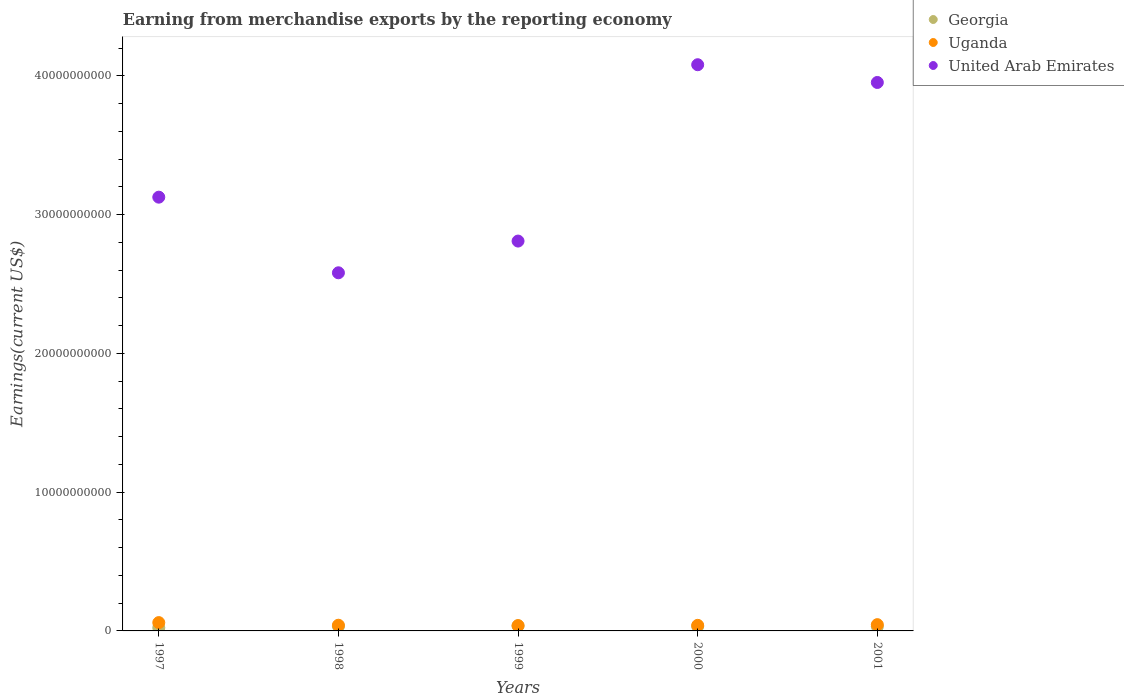What is the amount earned from merchandise exports in Georgia in 1997?
Keep it short and to the point. 2.30e+08. Across all years, what is the maximum amount earned from merchandise exports in United Arab Emirates?
Offer a terse response. 4.08e+1. Across all years, what is the minimum amount earned from merchandise exports in Uganda?
Offer a terse response. 3.85e+08. What is the total amount earned from merchandise exports in United Arab Emirates in the graph?
Offer a very short reply. 1.66e+11. What is the difference between the amount earned from merchandise exports in Uganda in 1999 and that in 2001?
Keep it short and to the point. -6.70e+07. What is the difference between the amount earned from merchandise exports in Uganda in 1997 and the amount earned from merchandise exports in Georgia in 1999?
Make the answer very short. 2.39e+08. What is the average amount earned from merchandise exports in Uganda per year?
Your answer should be compact. 4.50e+08. In the year 2001, what is the difference between the amount earned from merchandise exports in Uganda and amount earned from merchandise exports in United Arab Emirates?
Ensure brevity in your answer.  -3.91e+1. In how many years, is the amount earned from merchandise exports in Uganda greater than 20000000000 US$?
Your answer should be compact. 0. What is the ratio of the amount earned from merchandise exports in United Arab Emirates in 1998 to that in 2000?
Your answer should be compact. 0.63. Is the amount earned from merchandise exports in Uganda in 2000 less than that in 2001?
Offer a terse response. Yes. Is the difference between the amount earned from merchandise exports in Uganda in 2000 and 2001 greater than the difference between the amount earned from merchandise exports in United Arab Emirates in 2000 and 2001?
Your response must be concise. No. What is the difference between the highest and the second highest amount earned from merchandise exports in Georgia?
Your response must be concise. 3.02e+07. What is the difference between the highest and the lowest amount earned from merchandise exports in Uganda?
Keep it short and to the point. 2.15e+08. In how many years, is the amount earned from merchandise exports in Georgia greater than the average amount earned from merchandise exports in Georgia taken over all years?
Provide a short and direct response. 4. Is it the case that in every year, the sum of the amount earned from merchandise exports in United Arab Emirates and amount earned from merchandise exports in Uganda  is greater than the amount earned from merchandise exports in Georgia?
Ensure brevity in your answer.  Yes. Does the amount earned from merchandise exports in United Arab Emirates monotonically increase over the years?
Your response must be concise. No. Is the amount earned from merchandise exports in Uganda strictly less than the amount earned from merchandise exports in Georgia over the years?
Offer a very short reply. No. How many dotlines are there?
Provide a succinct answer. 3. How many legend labels are there?
Provide a short and direct response. 3. How are the legend labels stacked?
Your answer should be very brief. Vertical. What is the title of the graph?
Provide a succinct answer. Earning from merchandise exports by the reporting economy. What is the label or title of the Y-axis?
Your answer should be compact. Earnings(current US$). What is the Earnings(current US$) in Georgia in 1997?
Keep it short and to the point. 2.30e+08. What is the Earnings(current US$) of Uganda in 1997?
Your answer should be compact. 6.00e+08. What is the Earnings(current US$) in United Arab Emirates in 1997?
Provide a succinct answer. 3.13e+1. What is the Earnings(current US$) of Georgia in 1998?
Your response must be concise. 3.31e+08. What is the Earnings(current US$) in Uganda in 1998?
Provide a short and direct response. 4.11e+08. What is the Earnings(current US$) of United Arab Emirates in 1998?
Your response must be concise. 2.58e+1. What is the Earnings(current US$) in Georgia in 1999?
Ensure brevity in your answer.  3.61e+08. What is the Earnings(current US$) in Uganda in 1999?
Offer a very short reply. 3.85e+08. What is the Earnings(current US$) in United Arab Emirates in 1999?
Provide a short and direct response. 2.81e+1. What is the Earnings(current US$) in Georgia in 2000?
Your answer should be compact. 3.26e+08. What is the Earnings(current US$) in Uganda in 2000?
Offer a terse response. 4.02e+08. What is the Earnings(current US$) in United Arab Emirates in 2000?
Ensure brevity in your answer.  4.08e+1. What is the Earnings(current US$) in Georgia in 2001?
Provide a short and direct response. 3.17e+08. What is the Earnings(current US$) of Uganda in 2001?
Ensure brevity in your answer.  4.52e+08. What is the Earnings(current US$) in United Arab Emirates in 2001?
Provide a succinct answer. 3.95e+1. Across all years, what is the maximum Earnings(current US$) of Georgia?
Provide a succinct answer. 3.61e+08. Across all years, what is the maximum Earnings(current US$) in Uganda?
Provide a succinct answer. 6.00e+08. Across all years, what is the maximum Earnings(current US$) of United Arab Emirates?
Your answer should be very brief. 4.08e+1. Across all years, what is the minimum Earnings(current US$) in Georgia?
Your response must be concise. 2.30e+08. Across all years, what is the minimum Earnings(current US$) in Uganda?
Offer a very short reply. 3.85e+08. Across all years, what is the minimum Earnings(current US$) in United Arab Emirates?
Keep it short and to the point. 2.58e+1. What is the total Earnings(current US$) in Georgia in the graph?
Make the answer very short. 1.57e+09. What is the total Earnings(current US$) in Uganda in the graph?
Provide a short and direct response. 2.25e+09. What is the total Earnings(current US$) of United Arab Emirates in the graph?
Your answer should be compact. 1.66e+11. What is the difference between the Earnings(current US$) of Georgia in 1997 and that in 1998?
Offer a terse response. -1.01e+08. What is the difference between the Earnings(current US$) in Uganda in 1997 and that in 1998?
Ensure brevity in your answer.  1.89e+08. What is the difference between the Earnings(current US$) of United Arab Emirates in 1997 and that in 1998?
Your answer should be very brief. 5.45e+09. What is the difference between the Earnings(current US$) of Georgia in 1997 and that in 1999?
Ensure brevity in your answer.  -1.31e+08. What is the difference between the Earnings(current US$) in Uganda in 1997 and that in 1999?
Keep it short and to the point. 2.15e+08. What is the difference between the Earnings(current US$) in United Arab Emirates in 1997 and that in 1999?
Provide a short and direct response. 3.16e+09. What is the difference between the Earnings(current US$) in Georgia in 1997 and that in 2000?
Your answer should be very brief. -9.59e+07. What is the difference between the Earnings(current US$) in Uganda in 1997 and that in 2000?
Make the answer very short. 1.98e+08. What is the difference between the Earnings(current US$) in United Arab Emirates in 1997 and that in 2000?
Keep it short and to the point. -9.55e+09. What is the difference between the Earnings(current US$) in Georgia in 1997 and that in 2001?
Keep it short and to the point. -8.72e+07. What is the difference between the Earnings(current US$) in Uganda in 1997 and that in 2001?
Your answer should be very brief. 1.48e+08. What is the difference between the Earnings(current US$) of United Arab Emirates in 1997 and that in 2001?
Provide a short and direct response. -8.27e+09. What is the difference between the Earnings(current US$) in Georgia in 1998 and that in 1999?
Offer a terse response. -3.02e+07. What is the difference between the Earnings(current US$) of Uganda in 1998 and that in 1999?
Offer a very short reply. 2.61e+07. What is the difference between the Earnings(current US$) of United Arab Emirates in 1998 and that in 1999?
Offer a very short reply. -2.29e+09. What is the difference between the Earnings(current US$) in Georgia in 1998 and that in 2000?
Offer a terse response. 4.80e+06. What is the difference between the Earnings(current US$) in Uganda in 1998 and that in 2000?
Give a very brief answer. 9.03e+06. What is the difference between the Earnings(current US$) in United Arab Emirates in 1998 and that in 2000?
Provide a short and direct response. -1.50e+1. What is the difference between the Earnings(current US$) of Georgia in 1998 and that in 2001?
Keep it short and to the point. 1.35e+07. What is the difference between the Earnings(current US$) in Uganda in 1998 and that in 2001?
Offer a very short reply. -4.09e+07. What is the difference between the Earnings(current US$) in United Arab Emirates in 1998 and that in 2001?
Your answer should be very brief. -1.37e+1. What is the difference between the Earnings(current US$) in Georgia in 1999 and that in 2000?
Provide a short and direct response. 3.50e+07. What is the difference between the Earnings(current US$) in Uganda in 1999 and that in 2000?
Provide a short and direct response. -1.70e+07. What is the difference between the Earnings(current US$) in United Arab Emirates in 1999 and that in 2000?
Your answer should be compact. -1.27e+1. What is the difference between the Earnings(current US$) in Georgia in 1999 and that in 2001?
Provide a short and direct response. 4.37e+07. What is the difference between the Earnings(current US$) of Uganda in 1999 and that in 2001?
Your answer should be compact. -6.70e+07. What is the difference between the Earnings(current US$) of United Arab Emirates in 1999 and that in 2001?
Make the answer very short. -1.14e+1. What is the difference between the Earnings(current US$) in Georgia in 2000 and that in 2001?
Provide a succinct answer. 8.65e+06. What is the difference between the Earnings(current US$) in Uganda in 2000 and that in 2001?
Your response must be concise. -4.99e+07. What is the difference between the Earnings(current US$) in United Arab Emirates in 2000 and that in 2001?
Give a very brief answer. 1.28e+09. What is the difference between the Earnings(current US$) in Georgia in 1997 and the Earnings(current US$) in Uganda in 1998?
Keep it short and to the point. -1.81e+08. What is the difference between the Earnings(current US$) of Georgia in 1997 and the Earnings(current US$) of United Arab Emirates in 1998?
Offer a very short reply. -2.56e+1. What is the difference between the Earnings(current US$) in Uganda in 1997 and the Earnings(current US$) in United Arab Emirates in 1998?
Your answer should be compact. -2.52e+1. What is the difference between the Earnings(current US$) of Georgia in 1997 and the Earnings(current US$) of Uganda in 1999?
Your answer should be very brief. -1.54e+08. What is the difference between the Earnings(current US$) in Georgia in 1997 and the Earnings(current US$) in United Arab Emirates in 1999?
Your answer should be very brief. -2.79e+1. What is the difference between the Earnings(current US$) of Uganda in 1997 and the Earnings(current US$) of United Arab Emirates in 1999?
Provide a succinct answer. -2.75e+1. What is the difference between the Earnings(current US$) in Georgia in 1997 and the Earnings(current US$) in Uganda in 2000?
Your response must be concise. -1.72e+08. What is the difference between the Earnings(current US$) in Georgia in 1997 and the Earnings(current US$) in United Arab Emirates in 2000?
Your answer should be very brief. -4.06e+1. What is the difference between the Earnings(current US$) in Uganda in 1997 and the Earnings(current US$) in United Arab Emirates in 2000?
Provide a succinct answer. -4.02e+1. What is the difference between the Earnings(current US$) in Georgia in 1997 and the Earnings(current US$) in Uganda in 2001?
Your answer should be very brief. -2.21e+08. What is the difference between the Earnings(current US$) in Georgia in 1997 and the Earnings(current US$) in United Arab Emirates in 2001?
Ensure brevity in your answer.  -3.93e+1. What is the difference between the Earnings(current US$) of Uganda in 1997 and the Earnings(current US$) of United Arab Emirates in 2001?
Offer a very short reply. -3.89e+1. What is the difference between the Earnings(current US$) of Georgia in 1998 and the Earnings(current US$) of Uganda in 1999?
Give a very brief answer. -5.38e+07. What is the difference between the Earnings(current US$) in Georgia in 1998 and the Earnings(current US$) in United Arab Emirates in 1999?
Offer a terse response. -2.78e+1. What is the difference between the Earnings(current US$) in Uganda in 1998 and the Earnings(current US$) in United Arab Emirates in 1999?
Your response must be concise. -2.77e+1. What is the difference between the Earnings(current US$) in Georgia in 1998 and the Earnings(current US$) in Uganda in 2000?
Offer a very short reply. -7.08e+07. What is the difference between the Earnings(current US$) in Georgia in 1998 and the Earnings(current US$) in United Arab Emirates in 2000?
Your response must be concise. -4.05e+1. What is the difference between the Earnings(current US$) of Uganda in 1998 and the Earnings(current US$) of United Arab Emirates in 2000?
Provide a short and direct response. -4.04e+1. What is the difference between the Earnings(current US$) in Georgia in 1998 and the Earnings(current US$) in Uganda in 2001?
Your answer should be very brief. -1.21e+08. What is the difference between the Earnings(current US$) in Georgia in 1998 and the Earnings(current US$) in United Arab Emirates in 2001?
Your response must be concise. -3.92e+1. What is the difference between the Earnings(current US$) in Uganda in 1998 and the Earnings(current US$) in United Arab Emirates in 2001?
Ensure brevity in your answer.  -3.91e+1. What is the difference between the Earnings(current US$) in Georgia in 1999 and the Earnings(current US$) in Uganda in 2000?
Provide a short and direct response. -4.06e+07. What is the difference between the Earnings(current US$) in Georgia in 1999 and the Earnings(current US$) in United Arab Emirates in 2000?
Your answer should be very brief. -4.04e+1. What is the difference between the Earnings(current US$) in Uganda in 1999 and the Earnings(current US$) in United Arab Emirates in 2000?
Offer a very short reply. -4.04e+1. What is the difference between the Earnings(current US$) of Georgia in 1999 and the Earnings(current US$) of Uganda in 2001?
Ensure brevity in your answer.  -9.05e+07. What is the difference between the Earnings(current US$) of Georgia in 1999 and the Earnings(current US$) of United Arab Emirates in 2001?
Give a very brief answer. -3.92e+1. What is the difference between the Earnings(current US$) of Uganda in 1999 and the Earnings(current US$) of United Arab Emirates in 2001?
Your answer should be compact. -3.91e+1. What is the difference between the Earnings(current US$) of Georgia in 2000 and the Earnings(current US$) of Uganda in 2001?
Your answer should be compact. -1.26e+08. What is the difference between the Earnings(current US$) in Georgia in 2000 and the Earnings(current US$) in United Arab Emirates in 2001?
Provide a succinct answer. -3.92e+1. What is the difference between the Earnings(current US$) in Uganda in 2000 and the Earnings(current US$) in United Arab Emirates in 2001?
Offer a very short reply. -3.91e+1. What is the average Earnings(current US$) of Georgia per year?
Offer a very short reply. 3.13e+08. What is the average Earnings(current US$) of Uganda per year?
Offer a very short reply. 4.50e+08. What is the average Earnings(current US$) of United Arab Emirates per year?
Your answer should be compact. 3.31e+1. In the year 1997, what is the difference between the Earnings(current US$) of Georgia and Earnings(current US$) of Uganda?
Provide a short and direct response. -3.70e+08. In the year 1997, what is the difference between the Earnings(current US$) in Georgia and Earnings(current US$) in United Arab Emirates?
Ensure brevity in your answer.  -3.10e+1. In the year 1997, what is the difference between the Earnings(current US$) in Uganda and Earnings(current US$) in United Arab Emirates?
Provide a succinct answer. -3.07e+1. In the year 1998, what is the difference between the Earnings(current US$) of Georgia and Earnings(current US$) of Uganda?
Give a very brief answer. -7.99e+07. In the year 1998, what is the difference between the Earnings(current US$) in Georgia and Earnings(current US$) in United Arab Emirates?
Provide a succinct answer. -2.55e+1. In the year 1998, what is the difference between the Earnings(current US$) of Uganda and Earnings(current US$) of United Arab Emirates?
Provide a succinct answer. -2.54e+1. In the year 1999, what is the difference between the Earnings(current US$) in Georgia and Earnings(current US$) in Uganda?
Make the answer very short. -2.35e+07. In the year 1999, what is the difference between the Earnings(current US$) in Georgia and Earnings(current US$) in United Arab Emirates?
Make the answer very short. -2.77e+1. In the year 1999, what is the difference between the Earnings(current US$) of Uganda and Earnings(current US$) of United Arab Emirates?
Your answer should be very brief. -2.77e+1. In the year 2000, what is the difference between the Earnings(current US$) in Georgia and Earnings(current US$) in Uganda?
Offer a terse response. -7.56e+07. In the year 2000, what is the difference between the Earnings(current US$) in Georgia and Earnings(current US$) in United Arab Emirates?
Your answer should be compact. -4.05e+1. In the year 2000, what is the difference between the Earnings(current US$) in Uganda and Earnings(current US$) in United Arab Emirates?
Make the answer very short. -4.04e+1. In the year 2001, what is the difference between the Earnings(current US$) of Georgia and Earnings(current US$) of Uganda?
Give a very brief answer. -1.34e+08. In the year 2001, what is the difference between the Earnings(current US$) of Georgia and Earnings(current US$) of United Arab Emirates?
Provide a short and direct response. -3.92e+1. In the year 2001, what is the difference between the Earnings(current US$) of Uganda and Earnings(current US$) of United Arab Emirates?
Offer a terse response. -3.91e+1. What is the ratio of the Earnings(current US$) of Georgia in 1997 to that in 1998?
Keep it short and to the point. 0.7. What is the ratio of the Earnings(current US$) of Uganda in 1997 to that in 1998?
Offer a terse response. 1.46. What is the ratio of the Earnings(current US$) in United Arab Emirates in 1997 to that in 1998?
Give a very brief answer. 1.21. What is the ratio of the Earnings(current US$) of Georgia in 1997 to that in 1999?
Provide a succinct answer. 0.64. What is the ratio of the Earnings(current US$) in Uganda in 1997 to that in 1999?
Provide a succinct answer. 1.56. What is the ratio of the Earnings(current US$) in United Arab Emirates in 1997 to that in 1999?
Keep it short and to the point. 1.11. What is the ratio of the Earnings(current US$) in Georgia in 1997 to that in 2000?
Provide a succinct answer. 0.71. What is the ratio of the Earnings(current US$) in Uganda in 1997 to that in 2000?
Keep it short and to the point. 1.49. What is the ratio of the Earnings(current US$) in United Arab Emirates in 1997 to that in 2000?
Keep it short and to the point. 0.77. What is the ratio of the Earnings(current US$) in Georgia in 1997 to that in 2001?
Ensure brevity in your answer.  0.73. What is the ratio of the Earnings(current US$) in Uganda in 1997 to that in 2001?
Make the answer very short. 1.33. What is the ratio of the Earnings(current US$) in United Arab Emirates in 1997 to that in 2001?
Your response must be concise. 0.79. What is the ratio of the Earnings(current US$) in Georgia in 1998 to that in 1999?
Provide a succinct answer. 0.92. What is the ratio of the Earnings(current US$) in Uganda in 1998 to that in 1999?
Provide a short and direct response. 1.07. What is the ratio of the Earnings(current US$) of United Arab Emirates in 1998 to that in 1999?
Make the answer very short. 0.92. What is the ratio of the Earnings(current US$) of Georgia in 1998 to that in 2000?
Offer a terse response. 1.01. What is the ratio of the Earnings(current US$) in Uganda in 1998 to that in 2000?
Your answer should be very brief. 1.02. What is the ratio of the Earnings(current US$) in United Arab Emirates in 1998 to that in 2000?
Offer a terse response. 0.63. What is the ratio of the Earnings(current US$) of Georgia in 1998 to that in 2001?
Make the answer very short. 1.04. What is the ratio of the Earnings(current US$) of Uganda in 1998 to that in 2001?
Your response must be concise. 0.91. What is the ratio of the Earnings(current US$) of United Arab Emirates in 1998 to that in 2001?
Your response must be concise. 0.65. What is the ratio of the Earnings(current US$) of Georgia in 1999 to that in 2000?
Offer a very short reply. 1.11. What is the ratio of the Earnings(current US$) in Uganda in 1999 to that in 2000?
Your response must be concise. 0.96. What is the ratio of the Earnings(current US$) in United Arab Emirates in 1999 to that in 2000?
Keep it short and to the point. 0.69. What is the ratio of the Earnings(current US$) of Georgia in 1999 to that in 2001?
Keep it short and to the point. 1.14. What is the ratio of the Earnings(current US$) of Uganda in 1999 to that in 2001?
Your answer should be very brief. 0.85. What is the ratio of the Earnings(current US$) of United Arab Emirates in 1999 to that in 2001?
Offer a very short reply. 0.71. What is the ratio of the Earnings(current US$) in Georgia in 2000 to that in 2001?
Provide a short and direct response. 1.03. What is the ratio of the Earnings(current US$) in Uganda in 2000 to that in 2001?
Ensure brevity in your answer.  0.89. What is the ratio of the Earnings(current US$) in United Arab Emirates in 2000 to that in 2001?
Provide a succinct answer. 1.03. What is the difference between the highest and the second highest Earnings(current US$) of Georgia?
Your answer should be compact. 3.02e+07. What is the difference between the highest and the second highest Earnings(current US$) of Uganda?
Provide a short and direct response. 1.48e+08. What is the difference between the highest and the second highest Earnings(current US$) of United Arab Emirates?
Your answer should be very brief. 1.28e+09. What is the difference between the highest and the lowest Earnings(current US$) in Georgia?
Your answer should be compact. 1.31e+08. What is the difference between the highest and the lowest Earnings(current US$) in Uganda?
Make the answer very short. 2.15e+08. What is the difference between the highest and the lowest Earnings(current US$) in United Arab Emirates?
Your answer should be compact. 1.50e+1. 